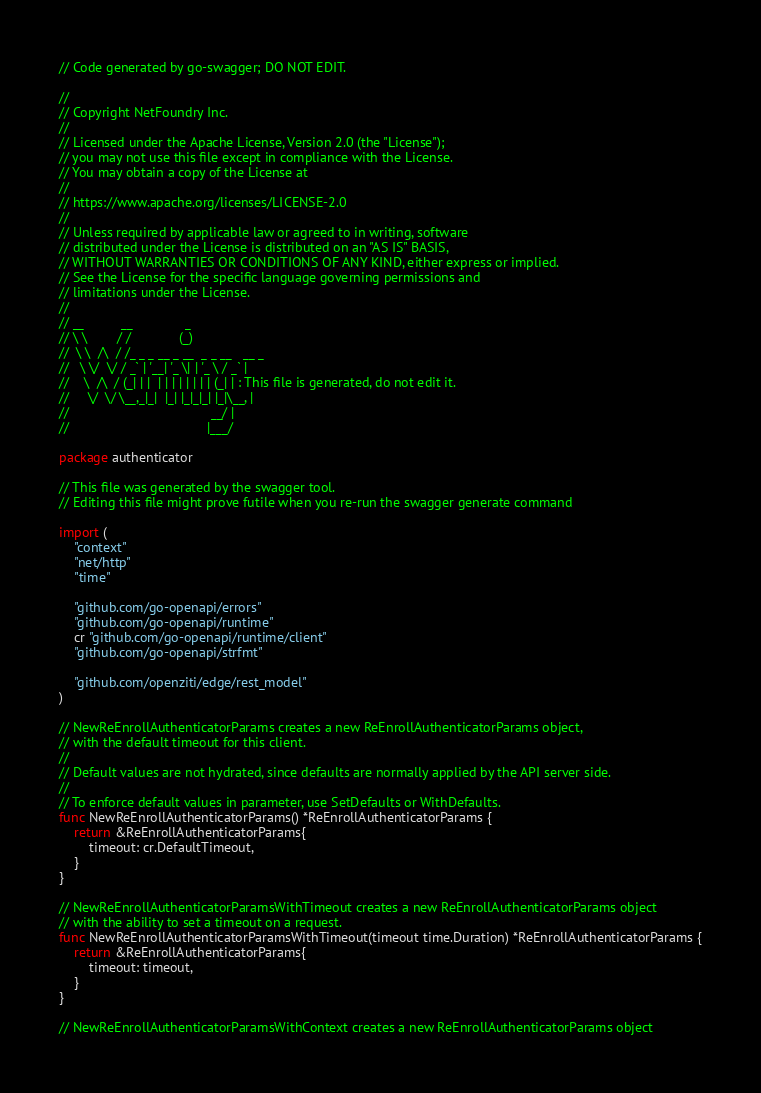<code> <loc_0><loc_0><loc_500><loc_500><_Go_>// Code generated by go-swagger; DO NOT EDIT.

//
// Copyright NetFoundry Inc.
//
// Licensed under the Apache License, Version 2.0 (the "License");
// you may not use this file except in compliance with the License.
// You may obtain a copy of the License at
//
// https://www.apache.org/licenses/LICENSE-2.0
//
// Unless required by applicable law or agreed to in writing, software
// distributed under the License is distributed on an "AS IS" BASIS,
// WITHOUT WARRANTIES OR CONDITIONS OF ANY KIND, either express or implied.
// See the License for the specific language governing permissions and
// limitations under the License.
//
// __          __              _
// \ \        / /             (_)
//  \ \  /\  / /_ _ _ __ _ __  _ _ __   __ _
//   \ \/  \/ / _` | '__| '_ \| | '_ \ / _` |
//    \  /\  / (_| | |  | | | | | | | | (_| | : This file is generated, do not edit it.
//     \/  \/ \__,_|_|  |_| |_|_|_| |_|\__, |
//                                      __/ |
//                                     |___/

package authenticator

// This file was generated by the swagger tool.
// Editing this file might prove futile when you re-run the swagger generate command

import (
	"context"
	"net/http"
	"time"

	"github.com/go-openapi/errors"
	"github.com/go-openapi/runtime"
	cr "github.com/go-openapi/runtime/client"
	"github.com/go-openapi/strfmt"

	"github.com/openziti/edge/rest_model"
)

// NewReEnrollAuthenticatorParams creates a new ReEnrollAuthenticatorParams object,
// with the default timeout for this client.
//
// Default values are not hydrated, since defaults are normally applied by the API server side.
//
// To enforce default values in parameter, use SetDefaults or WithDefaults.
func NewReEnrollAuthenticatorParams() *ReEnrollAuthenticatorParams {
	return &ReEnrollAuthenticatorParams{
		timeout: cr.DefaultTimeout,
	}
}

// NewReEnrollAuthenticatorParamsWithTimeout creates a new ReEnrollAuthenticatorParams object
// with the ability to set a timeout on a request.
func NewReEnrollAuthenticatorParamsWithTimeout(timeout time.Duration) *ReEnrollAuthenticatorParams {
	return &ReEnrollAuthenticatorParams{
		timeout: timeout,
	}
}

// NewReEnrollAuthenticatorParamsWithContext creates a new ReEnrollAuthenticatorParams object</code> 